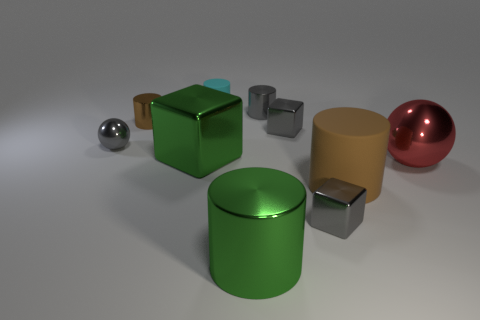What material is the big green thing that is the same shape as the small brown shiny object?
Offer a very short reply. Metal. There is a gray thing behind the brown shiny cylinder; what shape is it?
Your response must be concise. Cylinder. Are there any big green spheres that have the same material as the red object?
Give a very brief answer. No. Do the gray cylinder and the brown metallic thing have the same size?
Keep it short and to the point. Yes. What number of balls are either big green things or cyan things?
Provide a short and direct response. 0. There is a tiny cylinder that is the same color as the small sphere; what is it made of?
Offer a very short reply. Metal. How many big yellow shiny things are the same shape as the small matte object?
Your answer should be compact. 0. Is the number of big red shiny balls that are left of the large red thing greater than the number of balls that are left of the green metal block?
Offer a terse response. No. There is a small block that is behind the gray ball; does it have the same color as the big ball?
Ensure brevity in your answer.  No. The gray sphere is what size?
Provide a succinct answer. Small. 